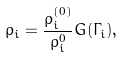<formula> <loc_0><loc_0><loc_500><loc_500>\bar { \rho } _ { i } = \frac { \rho _ { i } ^ { ( 0 ) } } { \rho _ { i } ^ { 0 } } G ( \Gamma _ { i } ) ,</formula> 